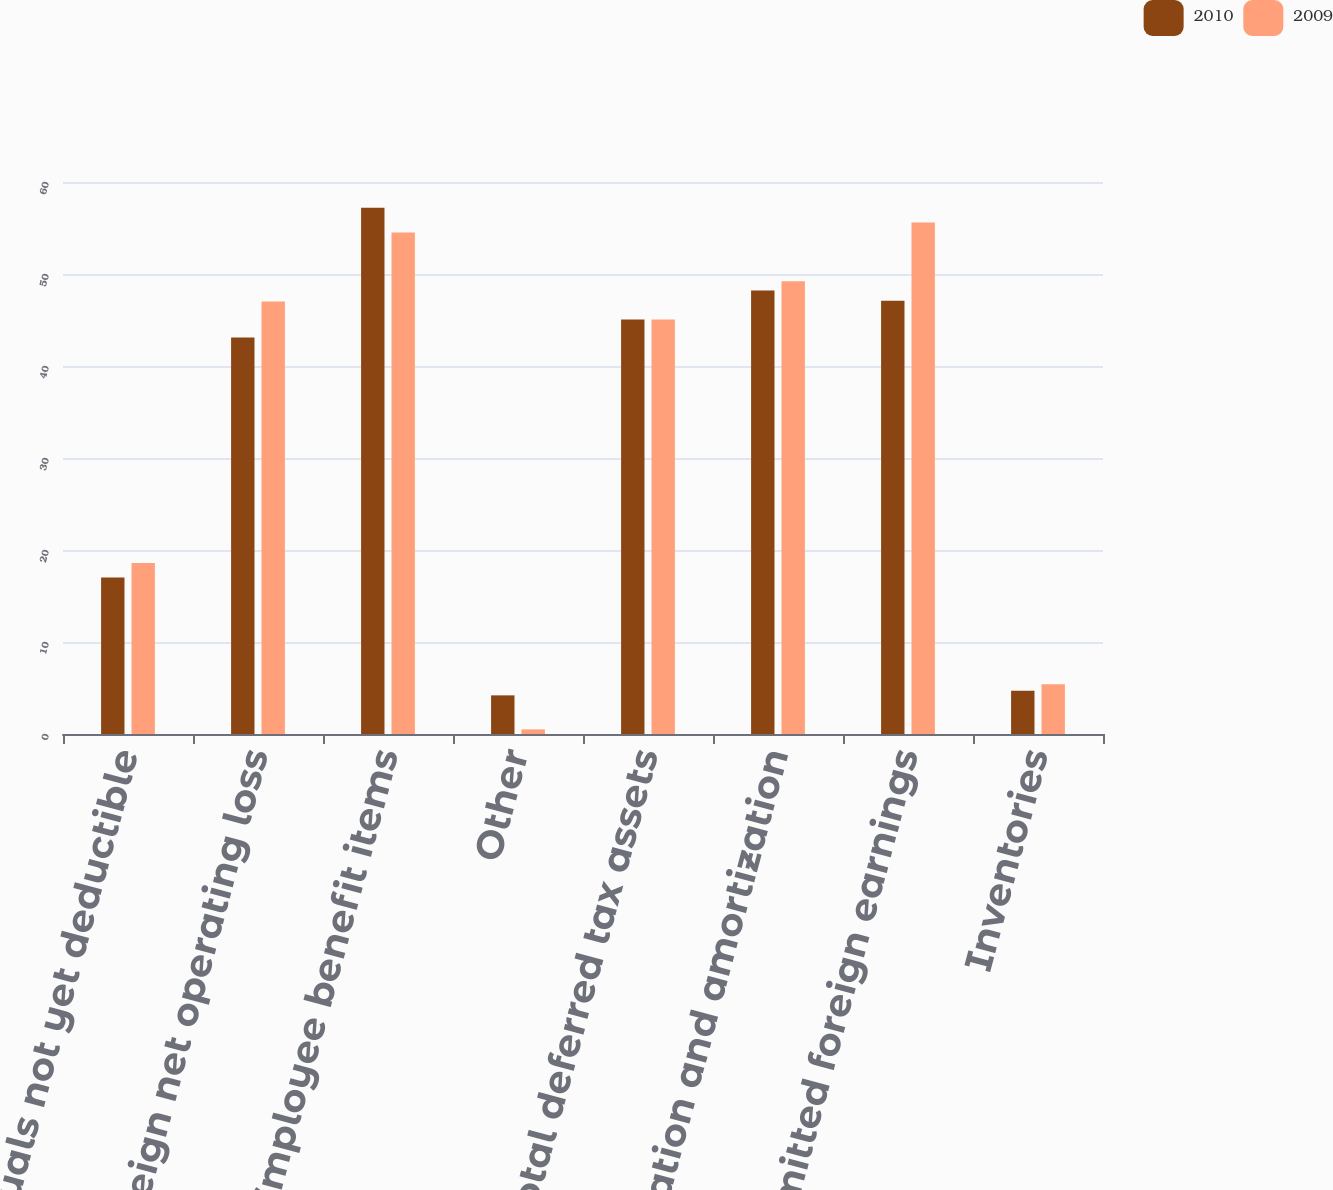Convert chart to OTSL. <chart><loc_0><loc_0><loc_500><loc_500><stacked_bar_chart><ecel><fcel>Accruals not yet deductible<fcel>Foreign net operating loss<fcel>Employee benefit items<fcel>Other<fcel>Total deferred tax assets<fcel>Depreciation and amortization<fcel>Unremitted foreign earnings<fcel>Inventories<nl><fcel>2010<fcel>17<fcel>43.1<fcel>57.2<fcel>4.2<fcel>45.05<fcel>48.2<fcel>47.1<fcel>4.7<nl><fcel>2009<fcel>18.6<fcel>47<fcel>54.5<fcel>0.5<fcel>45.05<fcel>49.2<fcel>55.6<fcel>5.4<nl></chart> 